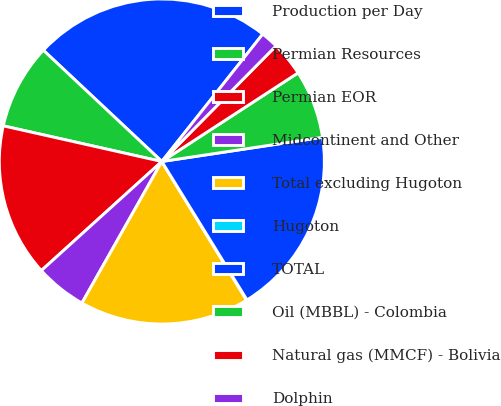Convert chart. <chart><loc_0><loc_0><loc_500><loc_500><pie_chart><fcel>Production per Day<fcel>Permian Resources<fcel>Permian EOR<fcel>Midcontinent and Other<fcel>Total excluding Hugoton<fcel>Hugoton<fcel>TOTAL<fcel>Oil (MBBL) - Colombia<fcel>Natural gas (MMCF) - Bolivia<fcel>Dolphin<nl><fcel>23.66%<fcel>8.48%<fcel>15.23%<fcel>5.11%<fcel>16.91%<fcel>0.05%<fcel>18.6%<fcel>6.8%<fcel>3.42%<fcel>1.74%<nl></chart> 